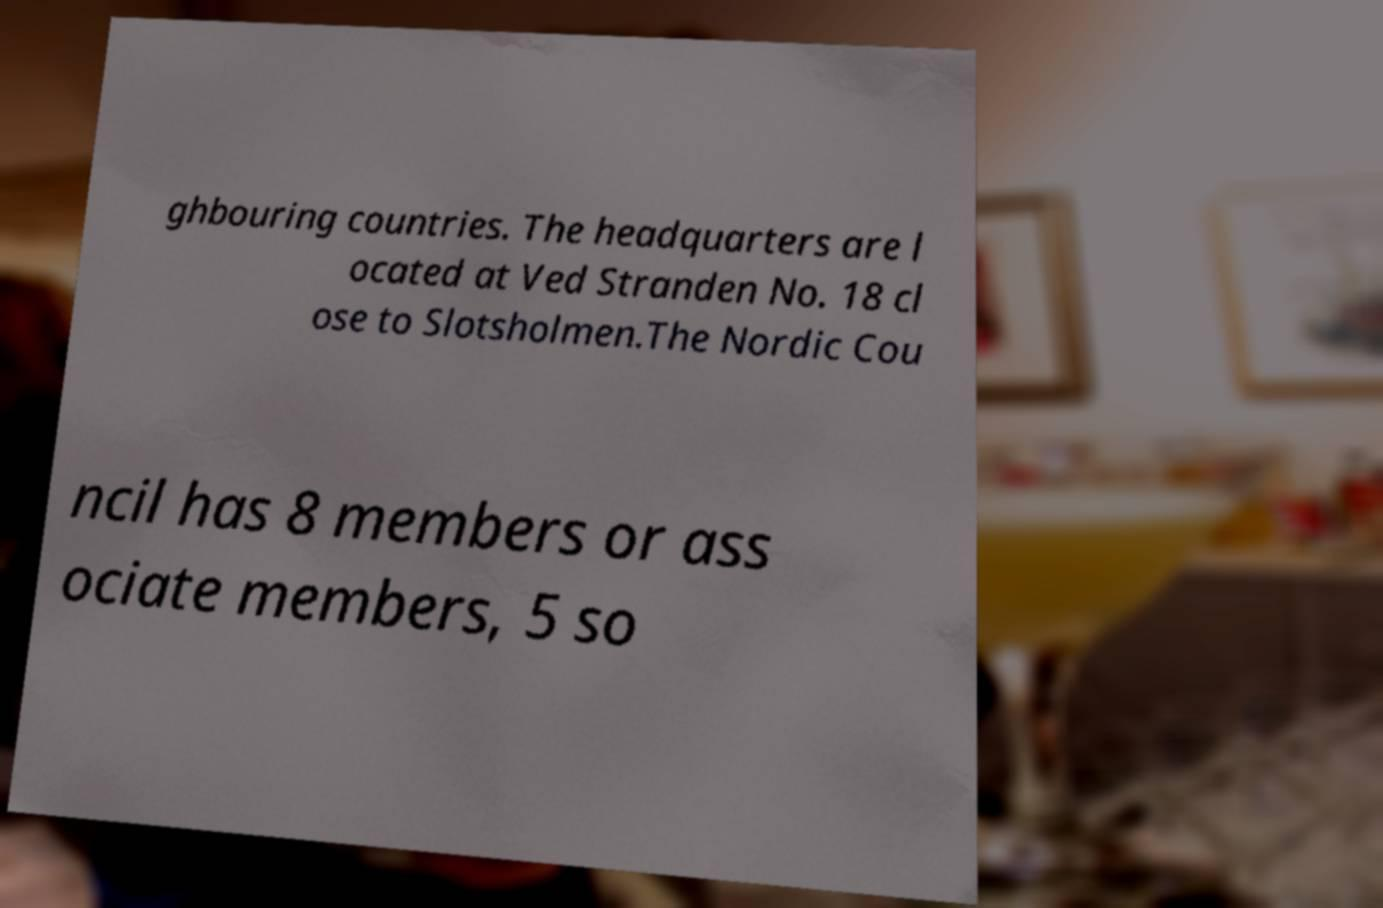Please read and relay the text visible in this image. What does it say? ghbouring countries. The headquarters are l ocated at Ved Stranden No. 18 cl ose to Slotsholmen.The Nordic Cou ncil has 8 members or ass ociate members, 5 so 